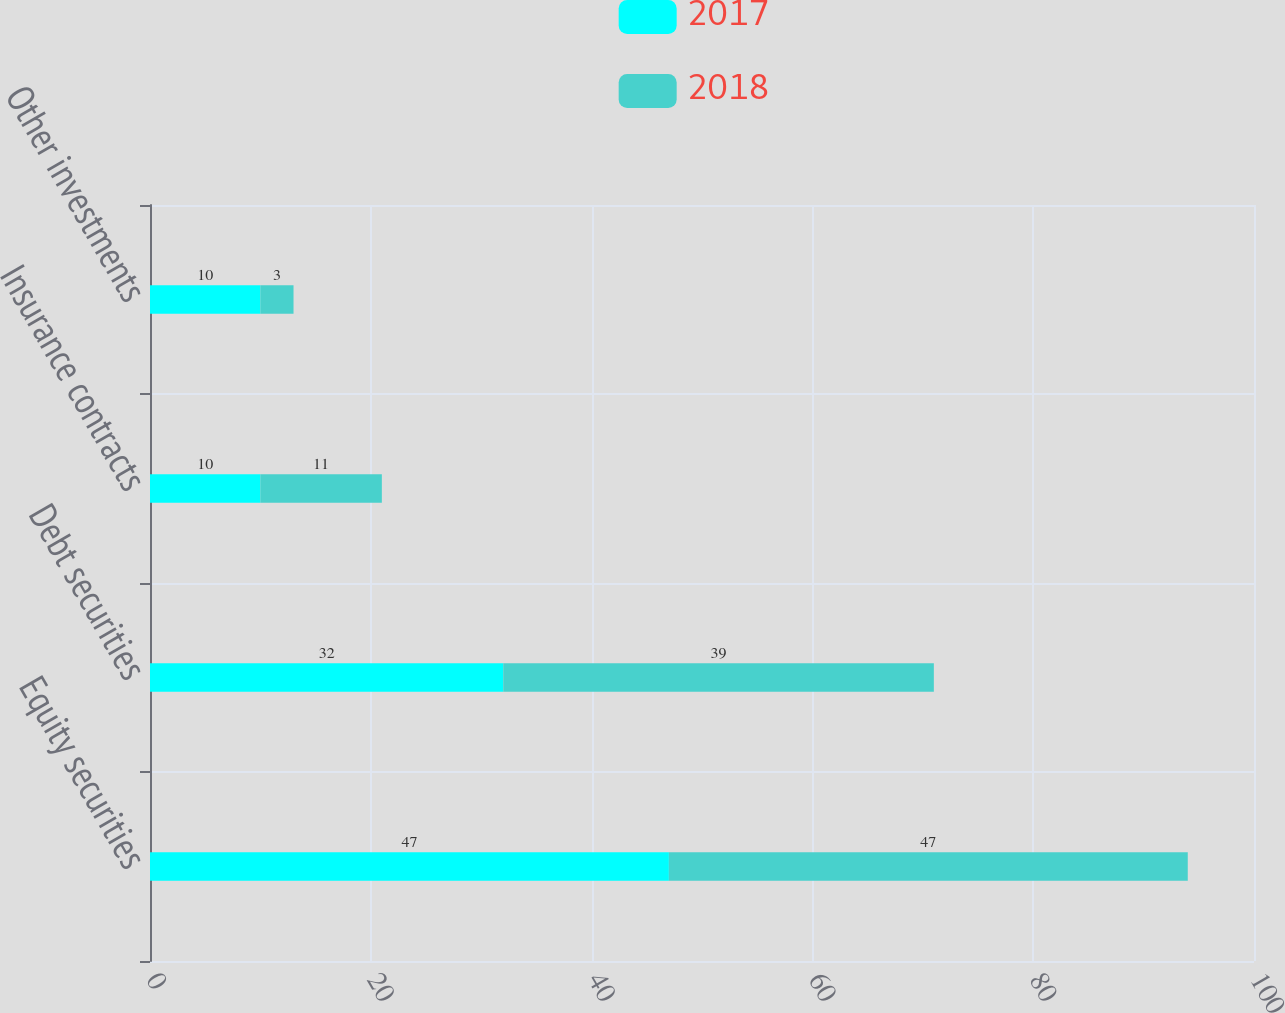Convert chart. <chart><loc_0><loc_0><loc_500><loc_500><stacked_bar_chart><ecel><fcel>Equity securities<fcel>Debt securities<fcel>Insurance contracts<fcel>Other investments<nl><fcel>2017<fcel>47<fcel>32<fcel>10<fcel>10<nl><fcel>2018<fcel>47<fcel>39<fcel>11<fcel>3<nl></chart> 